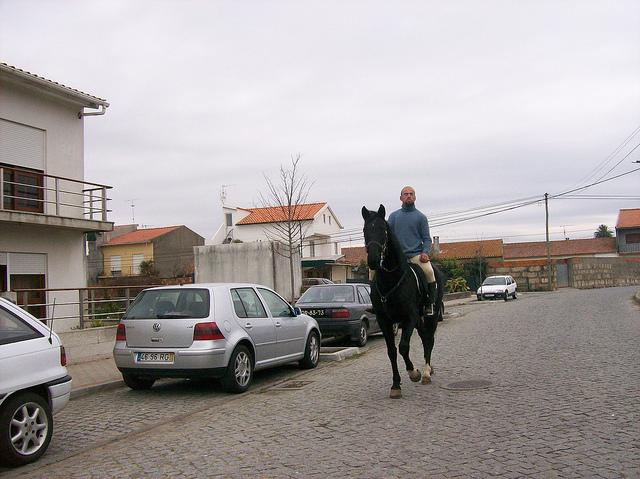What is he doing with the horse? riding 